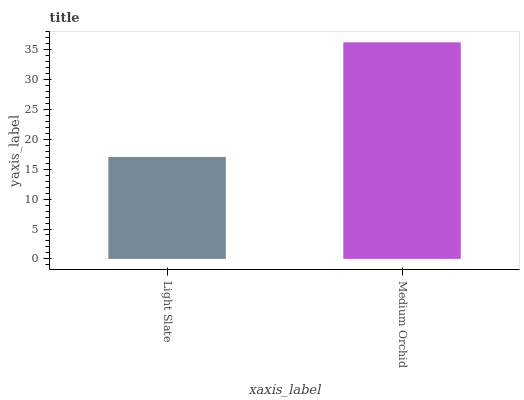Is Light Slate the minimum?
Answer yes or no. Yes. Is Medium Orchid the maximum?
Answer yes or no. Yes. Is Medium Orchid the minimum?
Answer yes or no. No. Is Medium Orchid greater than Light Slate?
Answer yes or no. Yes. Is Light Slate less than Medium Orchid?
Answer yes or no. Yes. Is Light Slate greater than Medium Orchid?
Answer yes or no. No. Is Medium Orchid less than Light Slate?
Answer yes or no. No. Is Medium Orchid the high median?
Answer yes or no. Yes. Is Light Slate the low median?
Answer yes or no. Yes. Is Light Slate the high median?
Answer yes or no. No. Is Medium Orchid the low median?
Answer yes or no. No. 